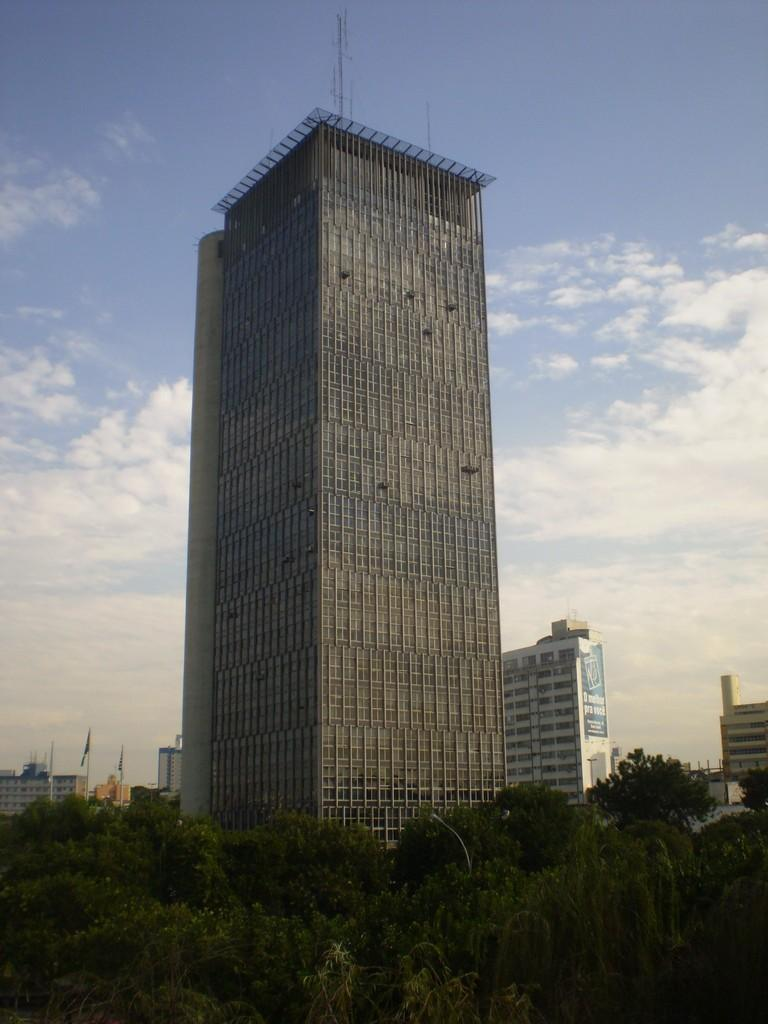What type of view is shown in the image? The image is an outside view. What can be seen at the bottom of the image? There are many trees at the bottom of the image. What is located in the middle of the image? There are buildings in the middle of the image. What is visible at the top of the image? The sky is visible at the top of the image. What can be observed in the sky? Clouds are present in the sky. What type of stocking is hanging from the tree in the image? There is no stocking hanging from a tree in the image. What is the reason for the protest taking place in the image? There is no protest taking place in the image. How many people have died in the image? There are no people depicted in the image, so it is impossible to determine if anyone has died. 